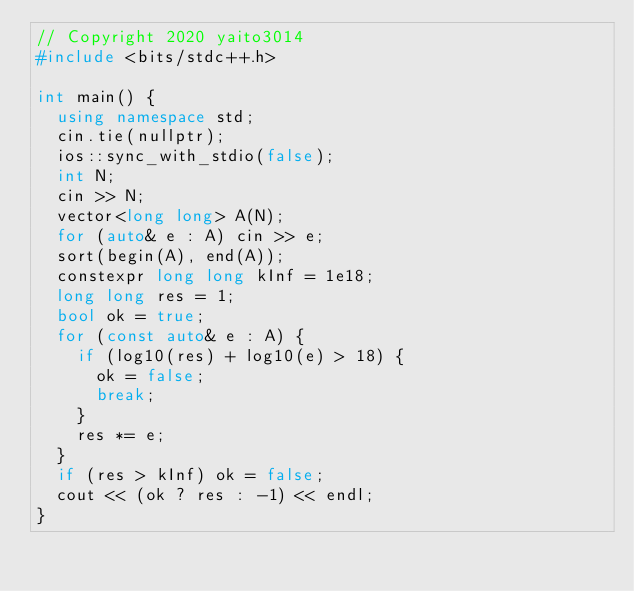<code> <loc_0><loc_0><loc_500><loc_500><_C++_>// Copyright 2020 yaito3014
#include <bits/stdc++.h>

int main() {
  using namespace std;
  cin.tie(nullptr);
  ios::sync_with_stdio(false);
  int N;
  cin >> N;
  vector<long long> A(N);
  for (auto& e : A) cin >> e;
  sort(begin(A), end(A));
  constexpr long long kInf = 1e18;
  long long res = 1;
  bool ok = true;
  for (const auto& e : A) {
    if (log10(res) + log10(e) > 18) {
      ok = false;
      break;
    }
    res *= e;
  }
  if (res > kInf) ok = false;
  cout << (ok ? res : -1) << endl;
}
</code> 